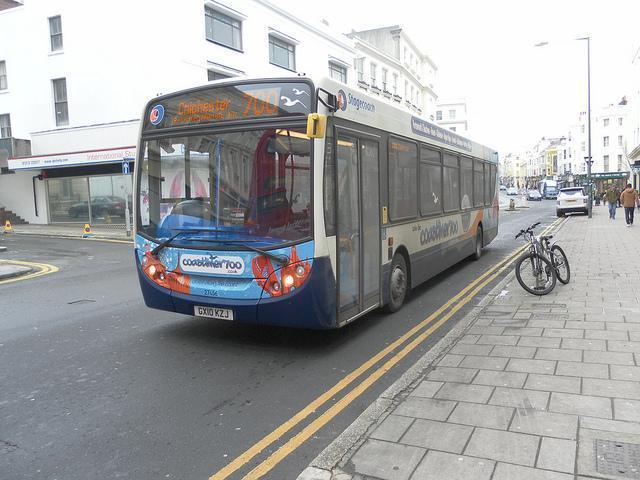How many zebras are standing in this image ?
Give a very brief answer. 0. 